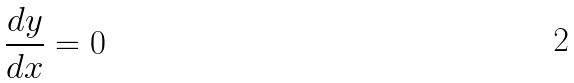Convert formula to latex. <formula><loc_0><loc_0><loc_500><loc_500>\frac { d y } { d x } = 0</formula> 